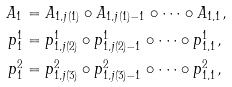Convert formula to latex. <formula><loc_0><loc_0><loc_500><loc_500>A _ { 1 } & = A _ { 1 , j ( 1 ) } \circ A _ { 1 , j ( 1 ) - 1 } \circ \dots \circ A _ { 1 , 1 } , \\ p _ { 1 } ^ { 1 } & = p _ { 1 , j ( 2 ) } ^ { 1 } \circ p _ { 1 , j ( 2 ) - 1 } ^ { 1 } \circ \dots \circ p _ { 1 , 1 } ^ { 1 } , \\ p _ { 1 } ^ { 2 } & = p _ { 1 , j ( 3 ) } ^ { 2 } \circ p _ { 1 , j ( 3 ) - 1 } ^ { 2 } \circ \dots \circ p _ { 1 , 1 } ^ { 2 } ,</formula> 